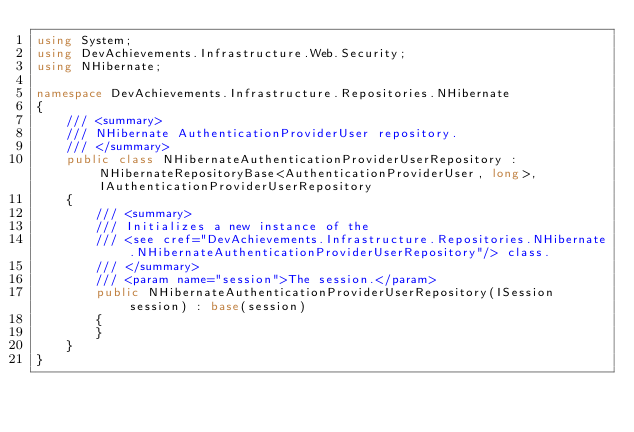<code> <loc_0><loc_0><loc_500><loc_500><_C#_>using System;
using DevAchievements.Infrastructure.Web.Security;
using NHibernate;

namespace DevAchievements.Infrastructure.Repositories.NHibernate
{
    /// <summary>
    /// NHibernate AuthenticationProviderUser repository.
    /// </summary>
    public class NHibernateAuthenticationProviderUserRepository : NHibernateRepositoryBase<AuthenticationProviderUser, long>, IAuthenticationProviderUserRepository
    {
        /// <summary>
        /// Initializes a new instance of the
        /// <see cref="DevAchievements.Infrastructure.Repositories.NHibernate.NHibernateAuthenticationProviderUserRepository"/> class.
        /// </summary>
        /// <param name="session">The session.</param>
        public NHibernateAuthenticationProviderUserRepository(ISession session) : base(session)
        {
        }
    }
}</code> 